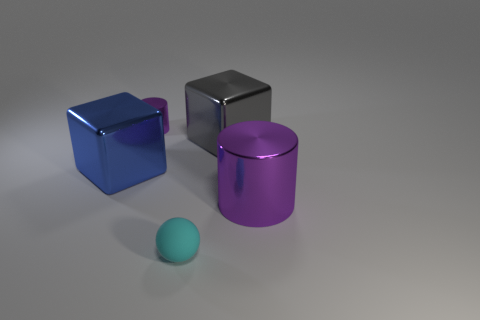Add 3 purple metallic objects. How many objects exist? 8 Subtract all gray cubes. How many cubes are left? 1 Subtract all balls. How many objects are left? 4 Subtract all cyan blocks. Subtract all blue balls. How many blocks are left? 2 Subtract all brown cylinders. How many blue cubes are left? 1 Subtract all blue objects. Subtract all big gray shiny cubes. How many objects are left? 3 Add 4 purple metallic things. How many purple metallic things are left? 6 Add 1 small metal cylinders. How many small metal cylinders exist? 2 Subtract 0 cyan cylinders. How many objects are left? 5 